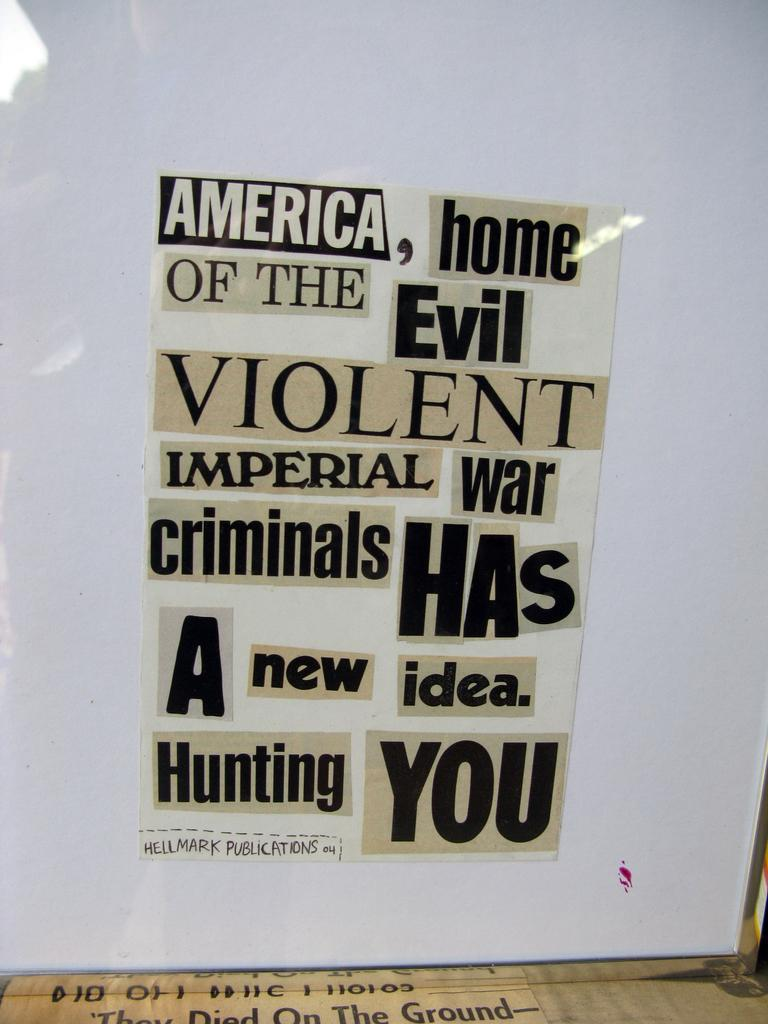<image>
Describe the image concisely. A collage of words including "America, home of the evil." 